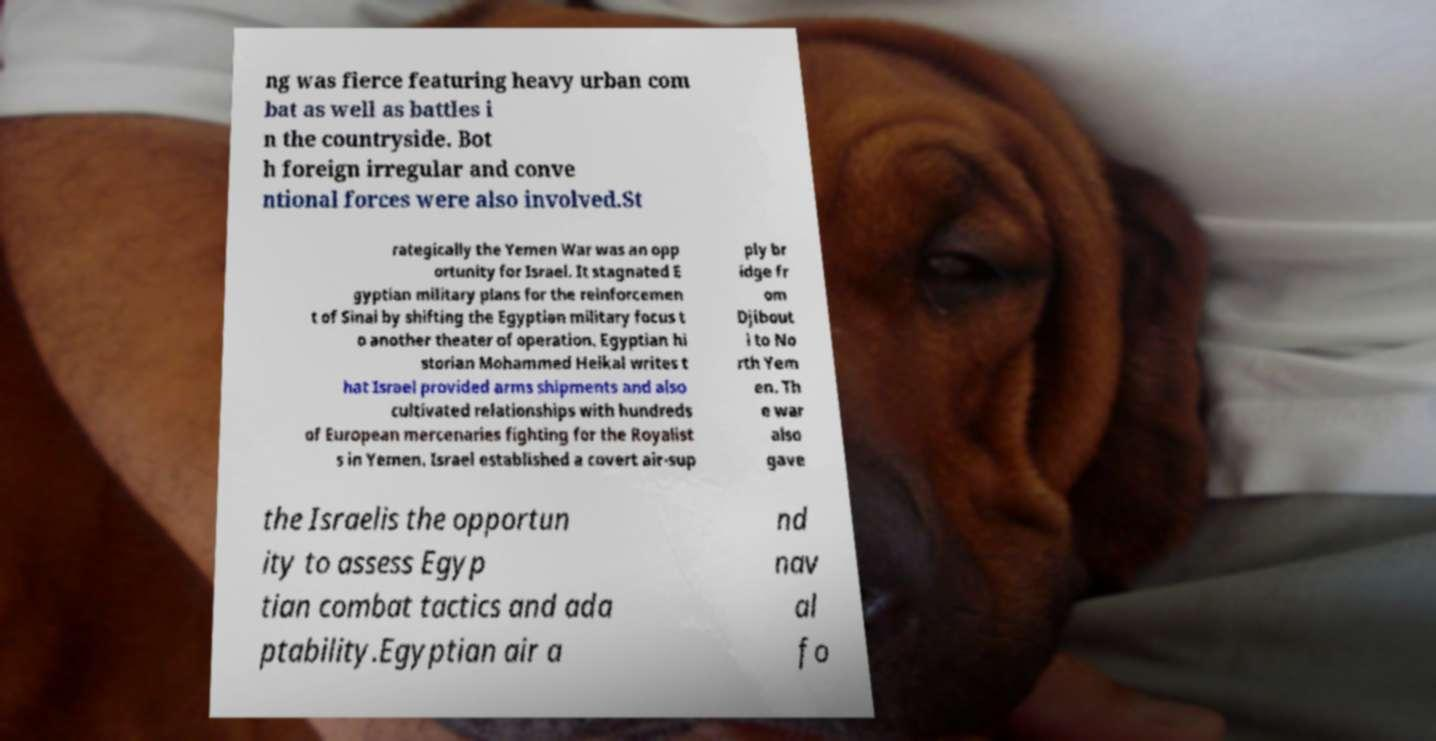Please identify and transcribe the text found in this image. ng was fierce featuring heavy urban com bat as well as battles i n the countryside. Bot h foreign irregular and conve ntional forces were also involved.St rategically the Yemen War was an opp ortunity for Israel. It stagnated E gyptian military plans for the reinforcemen t of Sinai by shifting the Egyptian military focus t o another theater of operation. Egyptian hi storian Mohammed Heikal writes t hat Israel provided arms shipments and also cultivated relationships with hundreds of European mercenaries fighting for the Royalist s in Yemen. Israel established a covert air-sup ply br idge fr om Djibout i to No rth Yem en. Th e war also gave the Israelis the opportun ity to assess Egyp tian combat tactics and ada ptability.Egyptian air a nd nav al fo 